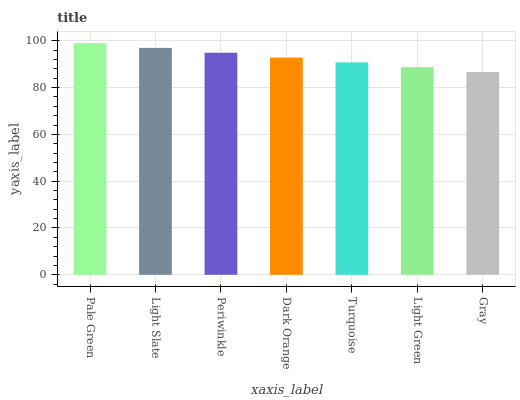Is Gray the minimum?
Answer yes or no. Yes. Is Pale Green the maximum?
Answer yes or no. Yes. Is Light Slate the minimum?
Answer yes or no. No. Is Light Slate the maximum?
Answer yes or no. No. Is Pale Green greater than Light Slate?
Answer yes or no. Yes. Is Light Slate less than Pale Green?
Answer yes or no. Yes. Is Light Slate greater than Pale Green?
Answer yes or no. No. Is Pale Green less than Light Slate?
Answer yes or no. No. Is Dark Orange the high median?
Answer yes or no. Yes. Is Dark Orange the low median?
Answer yes or no. Yes. Is Light Green the high median?
Answer yes or no. No. Is Light Green the low median?
Answer yes or no. No. 